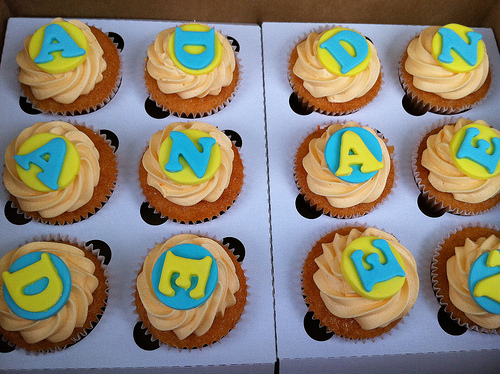<image>
Is there a cake to the left of the cake? No. The cake is not to the left of the cake. From this viewpoint, they have a different horizontal relationship. 